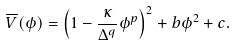<formula> <loc_0><loc_0><loc_500><loc_500>\overline { V } ( \phi ) = \left ( 1 - \frac { \kappa } { \Delta ^ { q } } \phi ^ { p } \right ) ^ { 2 } + b \phi ^ { 2 } + c .</formula> 